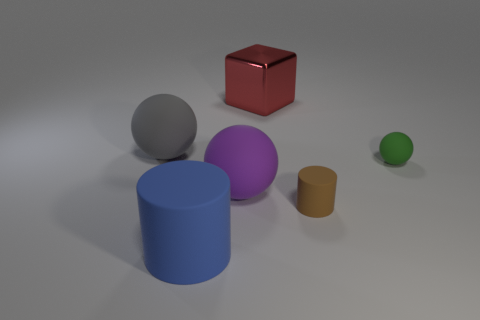Do the large sphere to the left of the blue matte thing and the sphere that is in front of the green matte object have the same material?
Provide a succinct answer. Yes. Is there anything else that has the same shape as the green matte thing?
Offer a very short reply. Yes. The cube is what color?
Give a very brief answer. Red. What number of large metal objects have the same shape as the big gray matte thing?
Your answer should be very brief. 0. What color is the matte cylinder that is the same size as the red object?
Keep it short and to the point. Blue. Is there a large blue rubber block?
Offer a terse response. No. What shape is the big matte thing behind the small green rubber thing?
Keep it short and to the point. Sphere. What number of rubber things are both to the left of the big purple rubber ball and behind the large blue rubber cylinder?
Offer a very short reply. 1. Is there a red cube made of the same material as the large purple thing?
Offer a terse response. No. What number of cylinders are tiny green things or big things?
Make the answer very short. 1. 